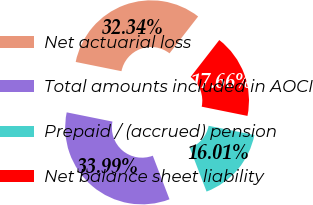<chart> <loc_0><loc_0><loc_500><loc_500><pie_chart><fcel>Net actuarial loss<fcel>Total amounts included in AOCI<fcel>Prepaid / (accrued) pension<fcel>Net balance sheet liability<nl><fcel>32.34%<fcel>33.99%<fcel>16.01%<fcel>17.66%<nl></chart> 